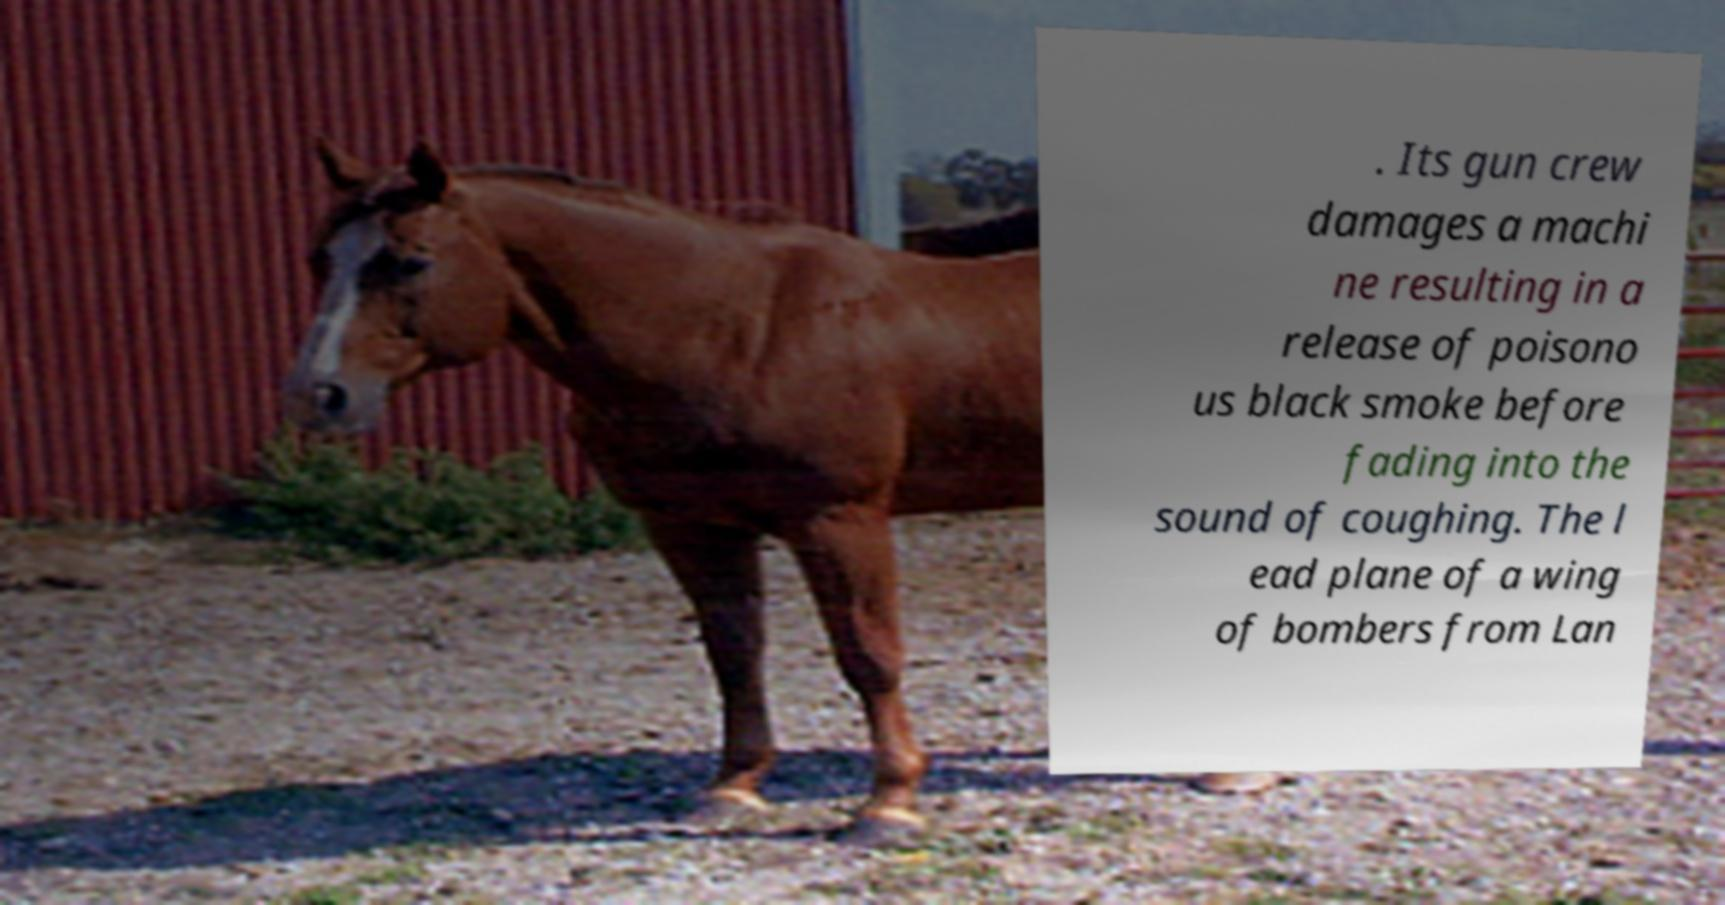There's text embedded in this image that I need extracted. Can you transcribe it verbatim? . Its gun crew damages a machi ne resulting in a release of poisono us black smoke before fading into the sound of coughing. The l ead plane of a wing of bombers from Lan 